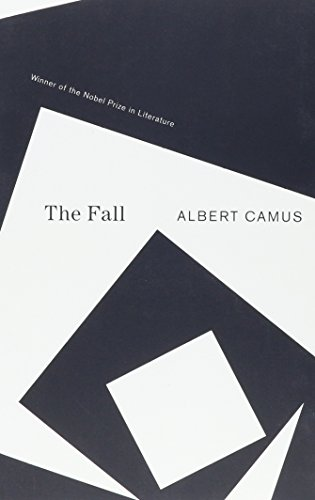What is the main theme explored in 'The Fall' by Albert Camus? The main theme explored in 'The Fall' is the concept of existential guilt and the human condition, where the protagonist confronts the truths about himself. 